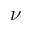<formula> <loc_0><loc_0><loc_500><loc_500>\nu</formula> 